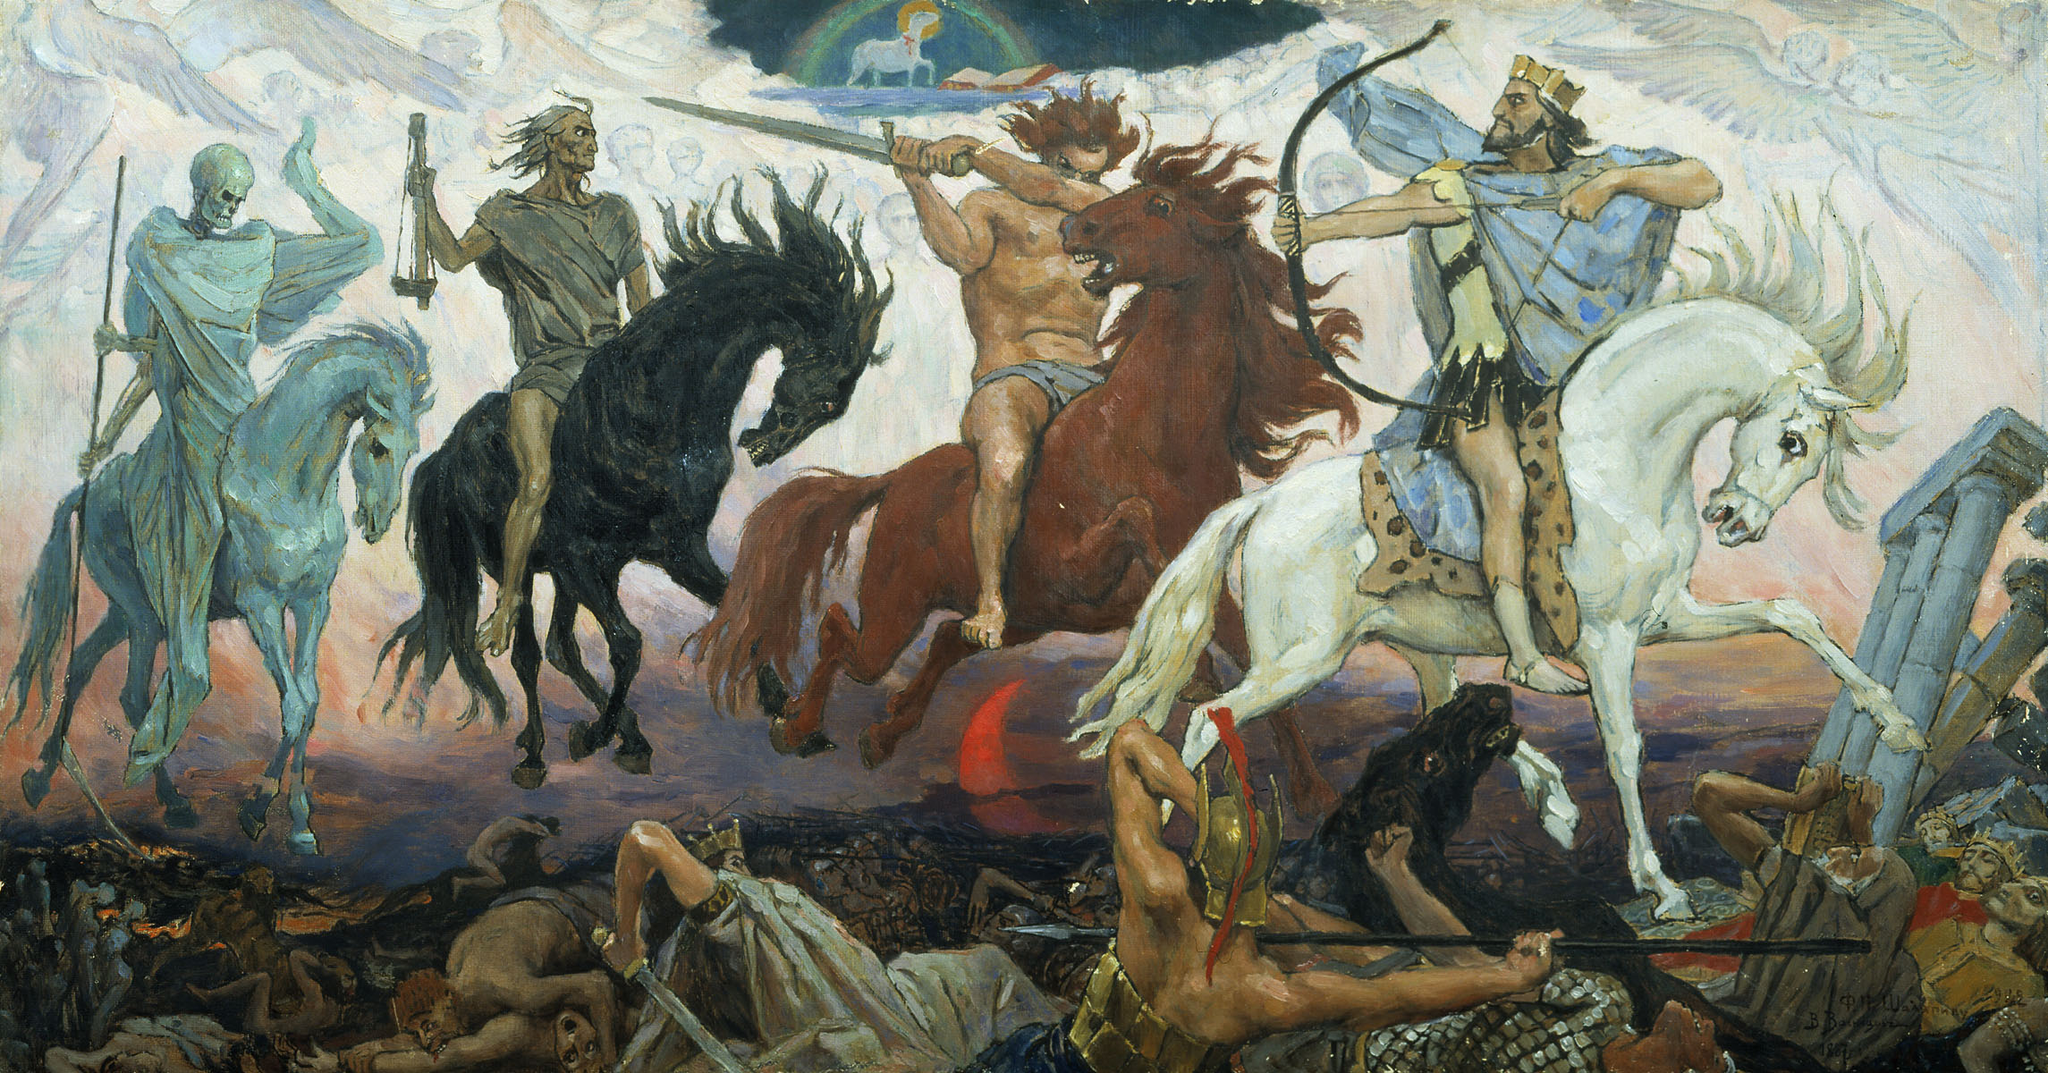Imagine a scene where these horsemen interact with modern-day elements. Describe it. In a surreal fusion of past and present, the Four Horsemen gallop through a bustling modern city. The skeletal figure of Death rides a glowing neon-blue horse, casting a spreading shadow over skyscrapers, dimming their lights. Conquest, on a white horse, wields a laser-studded crown that sends waves of control over the digital screens of Times Square. War, with a smoldering red sword, ignites urban chaos, his horse thundering past overturned cars and clashing protestors. Famine, riding a black steed, gestures with a digital scale, causing food supplies in supermarkets to dwindle to nothing in mere seconds. The juxtaposition of ancient apocalyptic figures within a modern, urban scenario highlights the perennial nature of the themes they represent, showing how conquest, war, famine, and death still hold relevance in the contemporary world. 